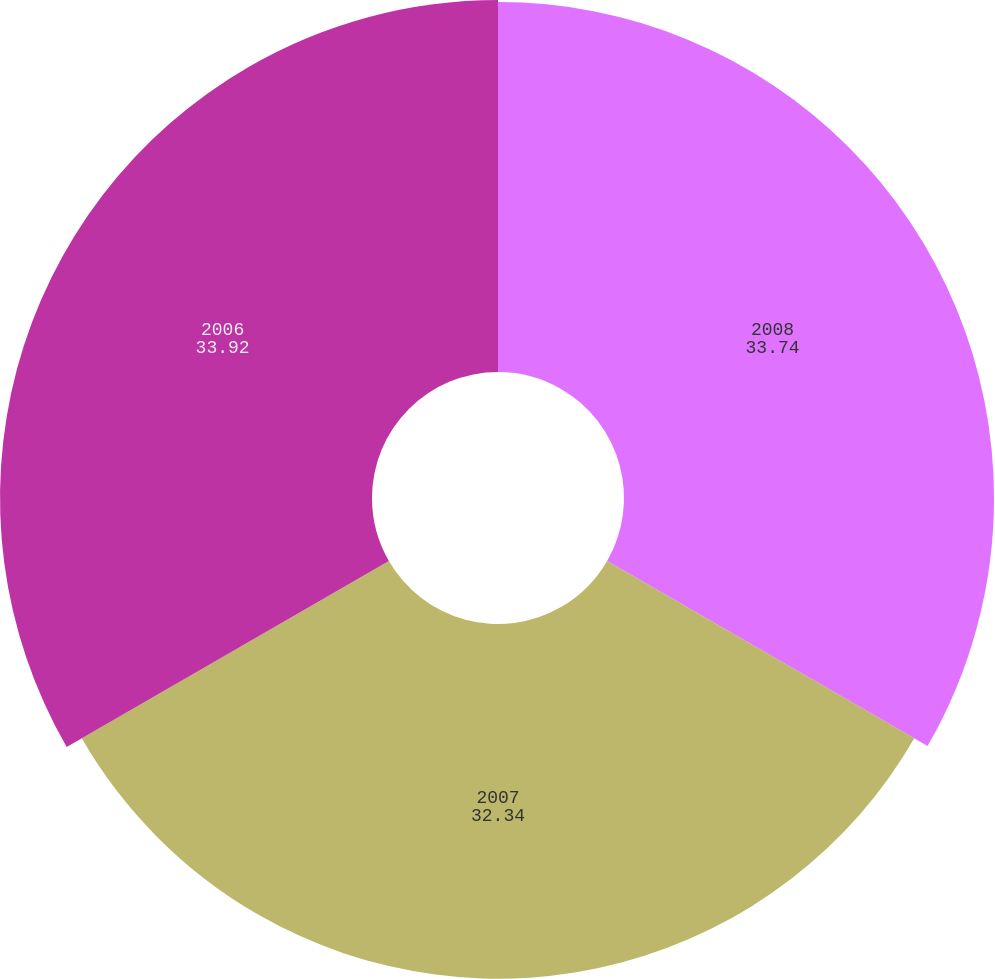Convert chart to OTSL. <chart><loc_0><loc_0><loc_500><loc_500><pie_chart><fcel>2008<fcel>2007<fcel>2006<nl><fcel>33.74%<fcel>32.34%<fcel>33.92%<nl></chart> 